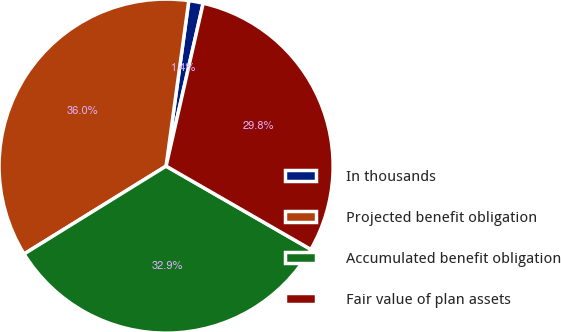<chart> <loc_0><loc_0><loc_500><loc_500><pie_chart><fcel>In thousands<fcel>Projected benefit obligation<fcel>Accumulated benefit obligation<fcel>Fair value of plan assets<nl><fcel>1.39%<fcel>35.99%<fcel>32.87%<fcel>29.75%<nl></chart> 